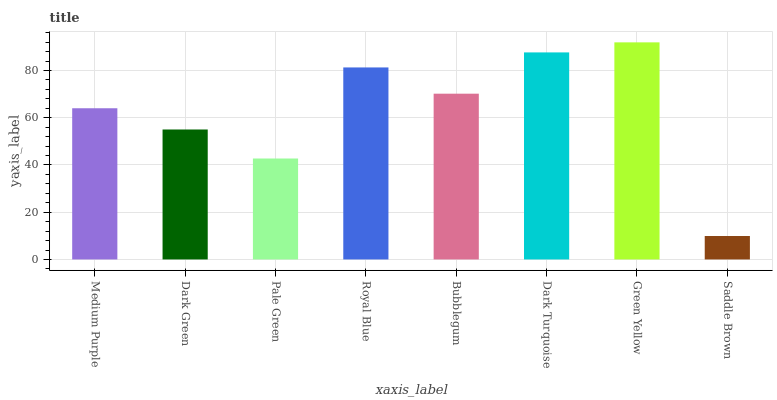Is Saddle Brown the minimum?
Answer yes or no. Yes. Is Green Yellow the maximum?
Answer yes or no. Yes. Is Dark Green the minimum?
Answer yes or no. No. Is Dark Green the maximum?
Answer yes or no. No. Is Medium Purple greater than Dark Green?
Answer yes or no. Yes. Is Dark Green less than Medium Purple?
Answer yes or no. Yes. Is Dark Green greater than Medium Purple?
Answer yes or no. No. Is Medium Purple less than Dark Green?
Answer yes or no. No. Is Bubblegum the high median?
Answer yes or no. Yes. Is Medium Purple the low median?
Answer yes or no. Yes. Is Green Yellow the high median?
Answer yes or no. No. Is Pale Green the low median?
Answer yes or no. No. 